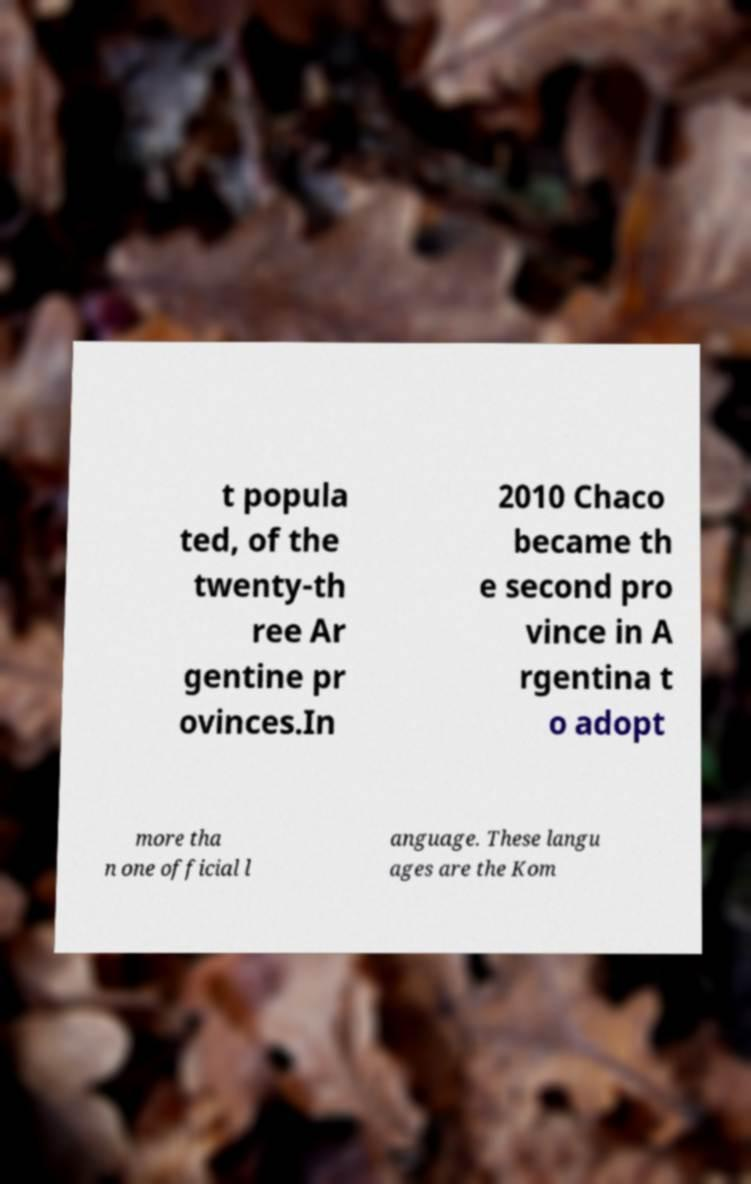Could you assist in decoding the text presented in this image and type it out clearly? t popula ted, of the twenty-th ree Ar gentine pr ovinces.In 2010 Chaco became th e second pro vince in A rgentina t o adopt more tha n one official l anguage. These langu ages are the Kom 